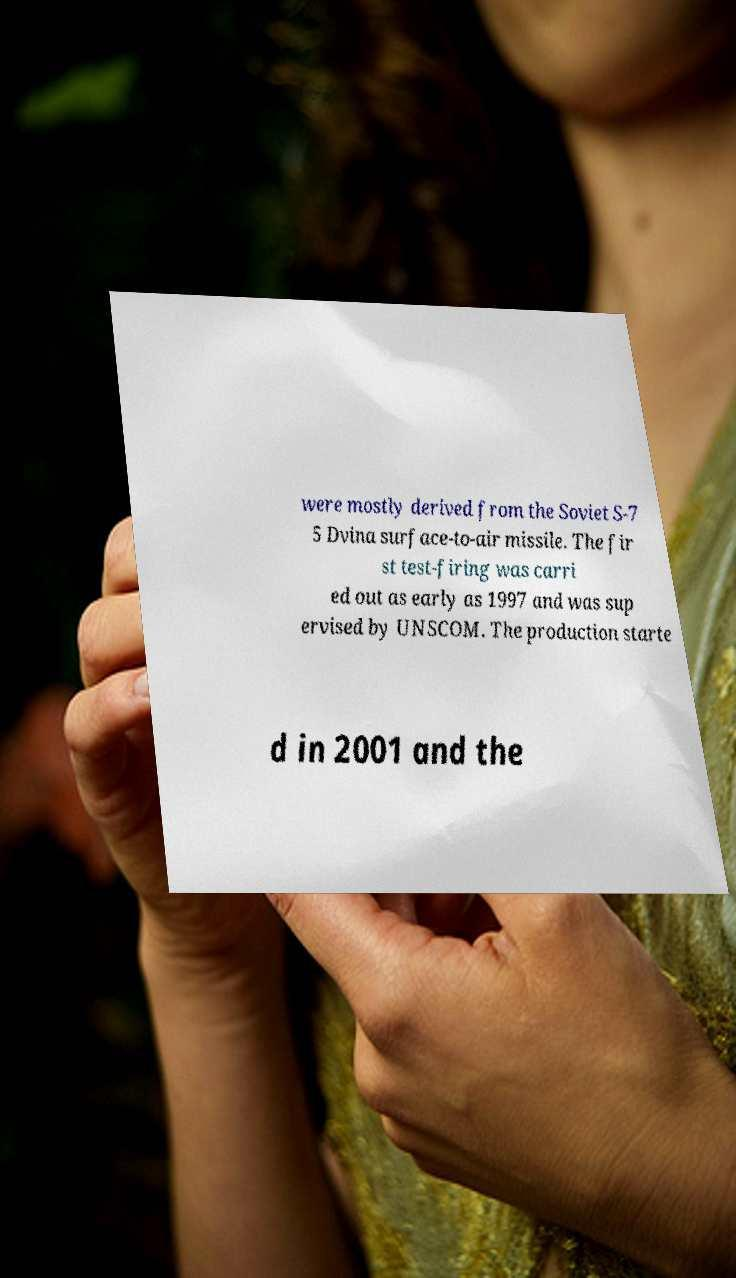There's text embedded in this image that I need extracted. Can you transcribe it verbatim? were mostly derived from the Soviet S-7 5 Dvina surface-to-air missile. The fir st test-firing was carri ed out as early as 1997 and was sup ervised by UNSCOM. The production starte d in 2001 and the 